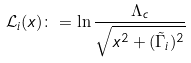Convert formula to latex. <formula><loc_0><loc_0><loc_500><loc_500>\mathcal { L } _ { i } ( x ) \colon = \ln \frac { \Lambda _ { c } } { \sqrt { x ^ { 2 } + ( \tilde { \Gamma } _ { i } ) ^ { 2 } } }</formula> 